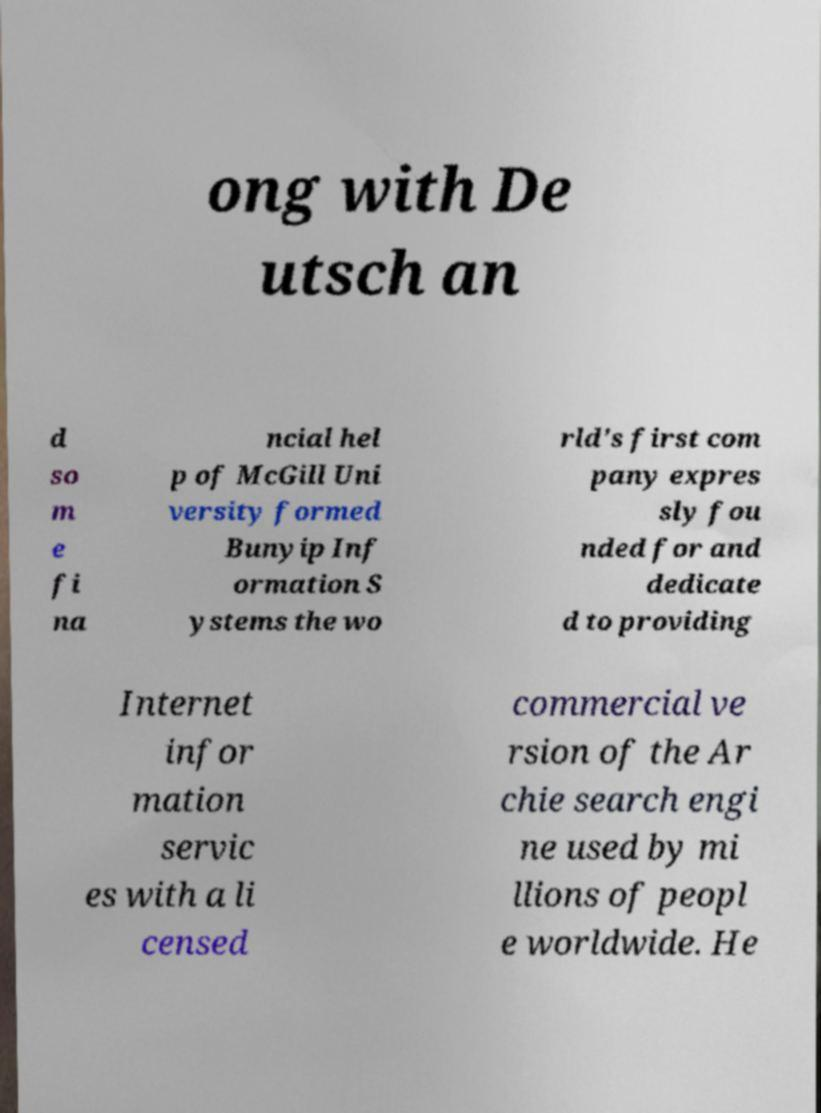Could you extract and type out the text from this image? ong with De utsch an d so m e fi na ncial hel p of McGill Uni versity formed Bunyip Inf ormation S ystems the wo rld's first com pany expres sly fou nded for and dedicate d to providing Internet infor mation servic es with a li censed commercial ve rsion of the Ar chie search engi ne used by mi llions of peopl e worldwide. He 